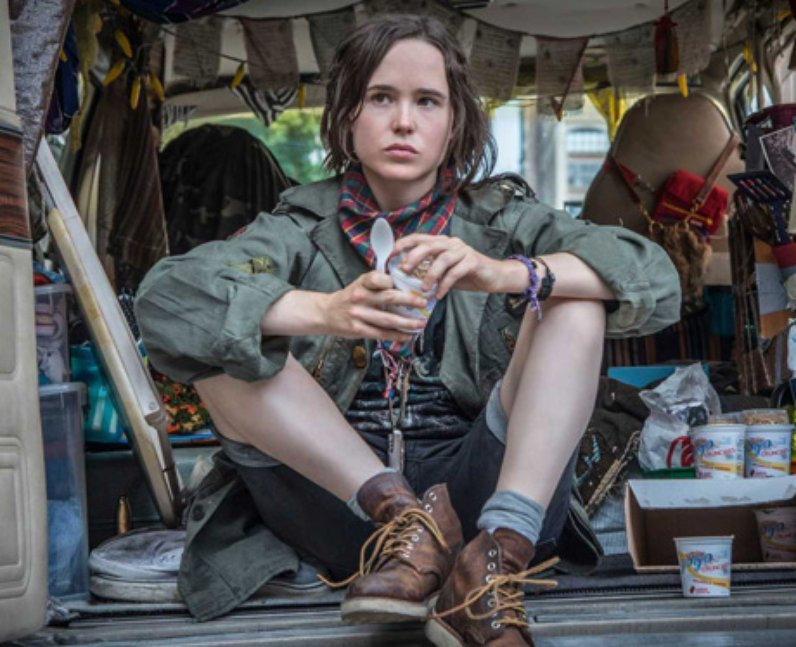What might be the challenges faced by this person living such a lifestyle? Living a nomadic lifestyle as depicted in the image can come with a variety of challenges. The person might struggle with a lack of stability and the constant need to find new places to park and stay. There could be difficulties in maintaining relationships and a sense of community due to always being on the move. Financial uncertainty and the need to make a living while traveling can also be significant stressors. Additionally, living in a confined space like a van requires careful organization and might lead to feelings of claustrophobia or isolation. 